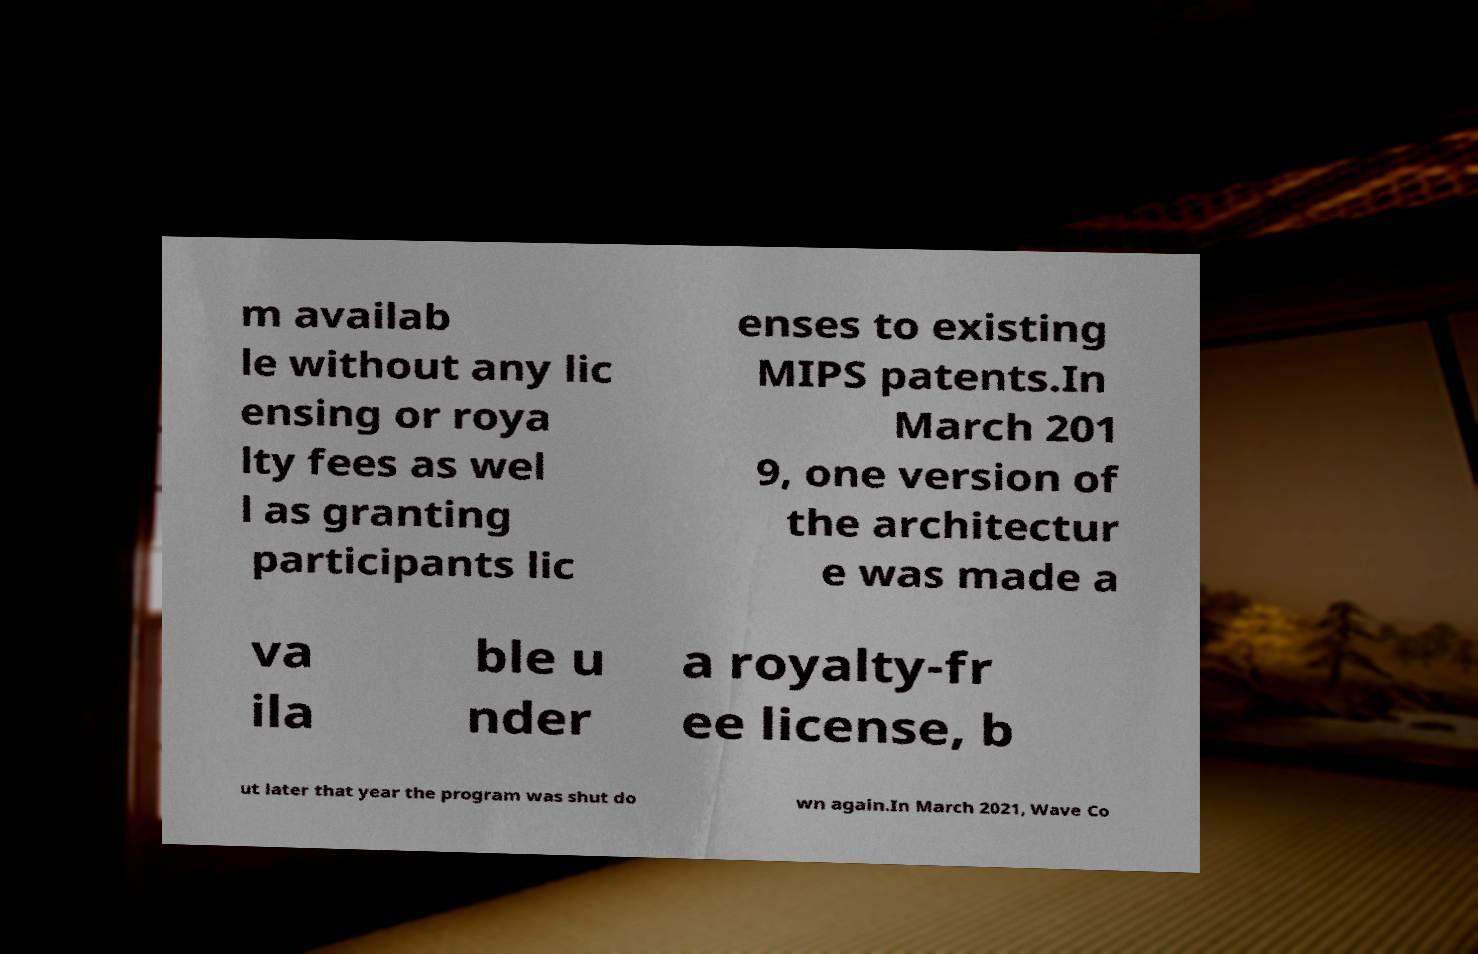For documentation purposes, I need the text within this image transcribed. Could you provide that? m availab le without any lic ensing or roya lty fees as wel l as granting participants lic enses to existing MIPS patents.In March 201 9, one version of the architectur e was made a va ila ble u nder a royalty-fr ee license, b ut later that year the program was shut do wn again.In March 2021, Wave Co 